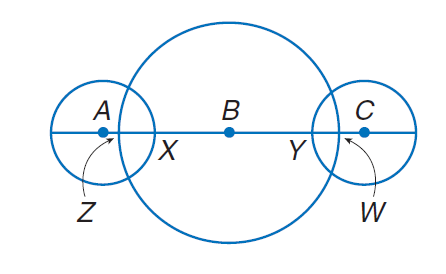Answer the mathemtical geometry problem and directly provide the correct option letter.
Question: The diameters of \odot A, \odot B, and \odot C are 10, 30 and 10 units, respectively. Find B Y if A Z \cong C W and C W = 2.
Choices: A: 6 B: 12 C: 48 D: 60 B 